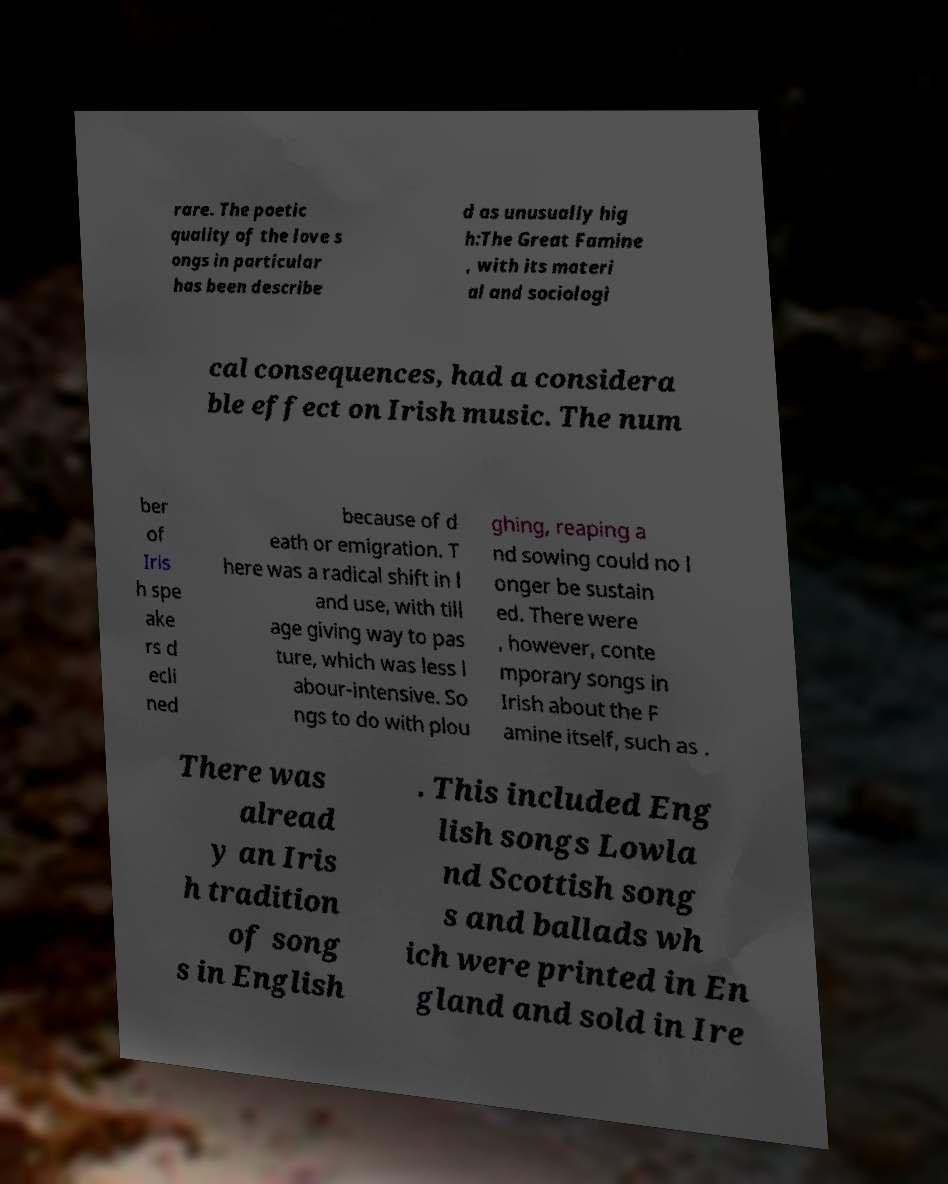There's text embedded in this image that I need extracted. Can you transcribe it verbatim? rare. The poetic quality of the love s ongs in particular has been describe d as unusually hig h:The Great Famine , with its materi al and sociologi cal consequences, had a considera ble effect on Irish music. The num ber of Iris h spe ake rs d ecli ned because of d eath or emigration. T here was a radical shift in l and use, with till age giving way to pas ture, which was less l abour-intensive. So ngs to do with plou ghing, reaping a nd sowing could no l onger be sustain ed. There were , however, conte mporary songs in Irish about the F amine itself, such as . There was alread y an Iris h tradition of song s in English . This included Eng lish songs Lowla nd Scottish song s and ballads wh ich were printed in En gland and sold in Ire 